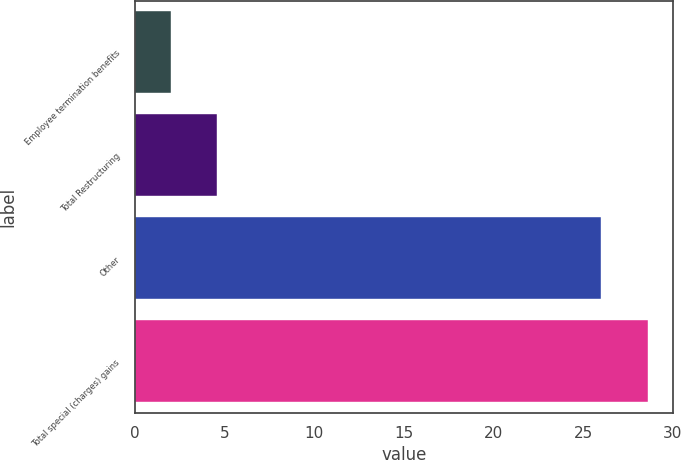Convert chart. <chart><loc_0><loc_0><loc_500><loc_500><bar_chart><fcel>Employee termination benefits<fcel>Total Restructuring<fcel>Other<fcel>Total special (charges) gains<nl><fcel>2<fcel>4.6<fcel>26<fcel>28.6<nl></chart> 